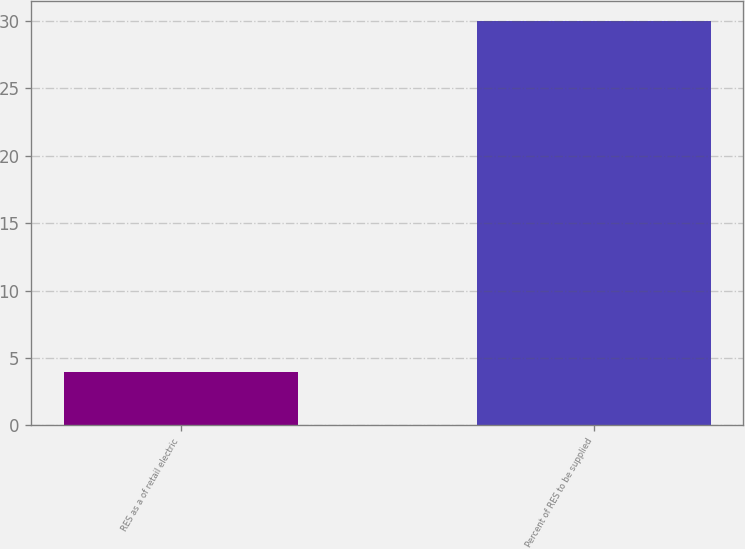<chart> <loc_0><loc_0><loc_500><loc_500><bar_chart><fcel>RES as a of retail electric<fcel>Percent of RES to be supplied<nl><fcel>4<fcel>30<nl></chart> 